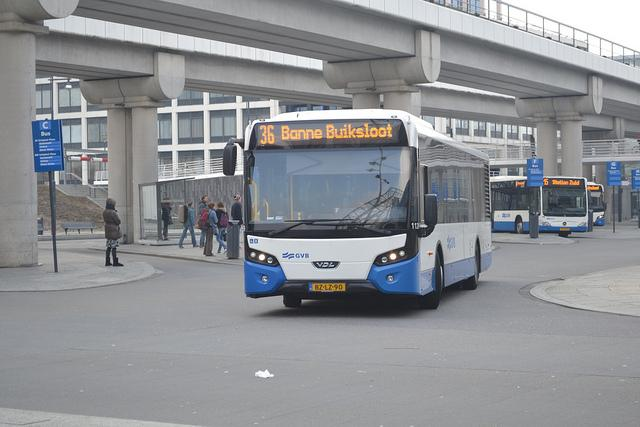Where are these people probably waiting to catch a bus? Please explain your reasoning. terminal. The people are at a terminal. 